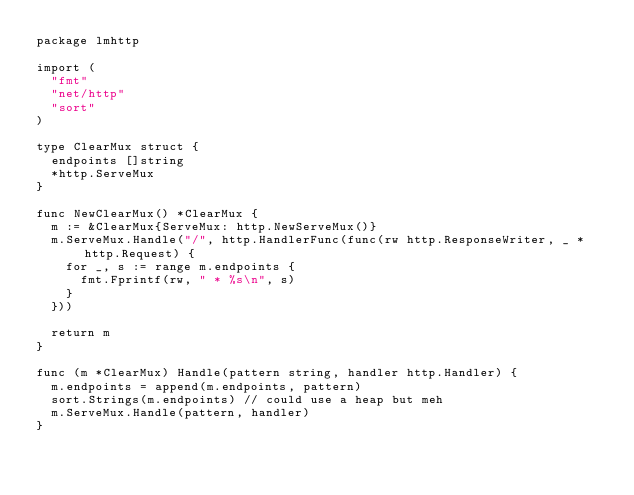<code> <loc_0><loc_0><loc_500><loc_500><_Go_>package lmhttp

import (
	"fmt"
	"net/http"
	"sort"
)

type ClearMux struct {
	endpoints []string
	*http.ServeMux
}

func NewClearMux() *ClearMux {
	m := &ClearMux{ServeMux: http.NewServeMux()}
	m.ServeMux.Handle("/", http.HandlerFunc(func(rw http.ResponseWriter, _ *http.Request) {
		for _, s := range m.endpoints {
			fmt.Fprintf(rw, " * %s\n", s)
		}
	}))

	return m
}

func (m *ClearMux) Handle(pattern string, handler http.Handler) {
	m.endpoints = append(m.endpoints, pattern)
	sort.Strings(m.endpoints) // could use a heap but meh
	m.ServeMux.Handle(pattern, handler)
}
</code> 